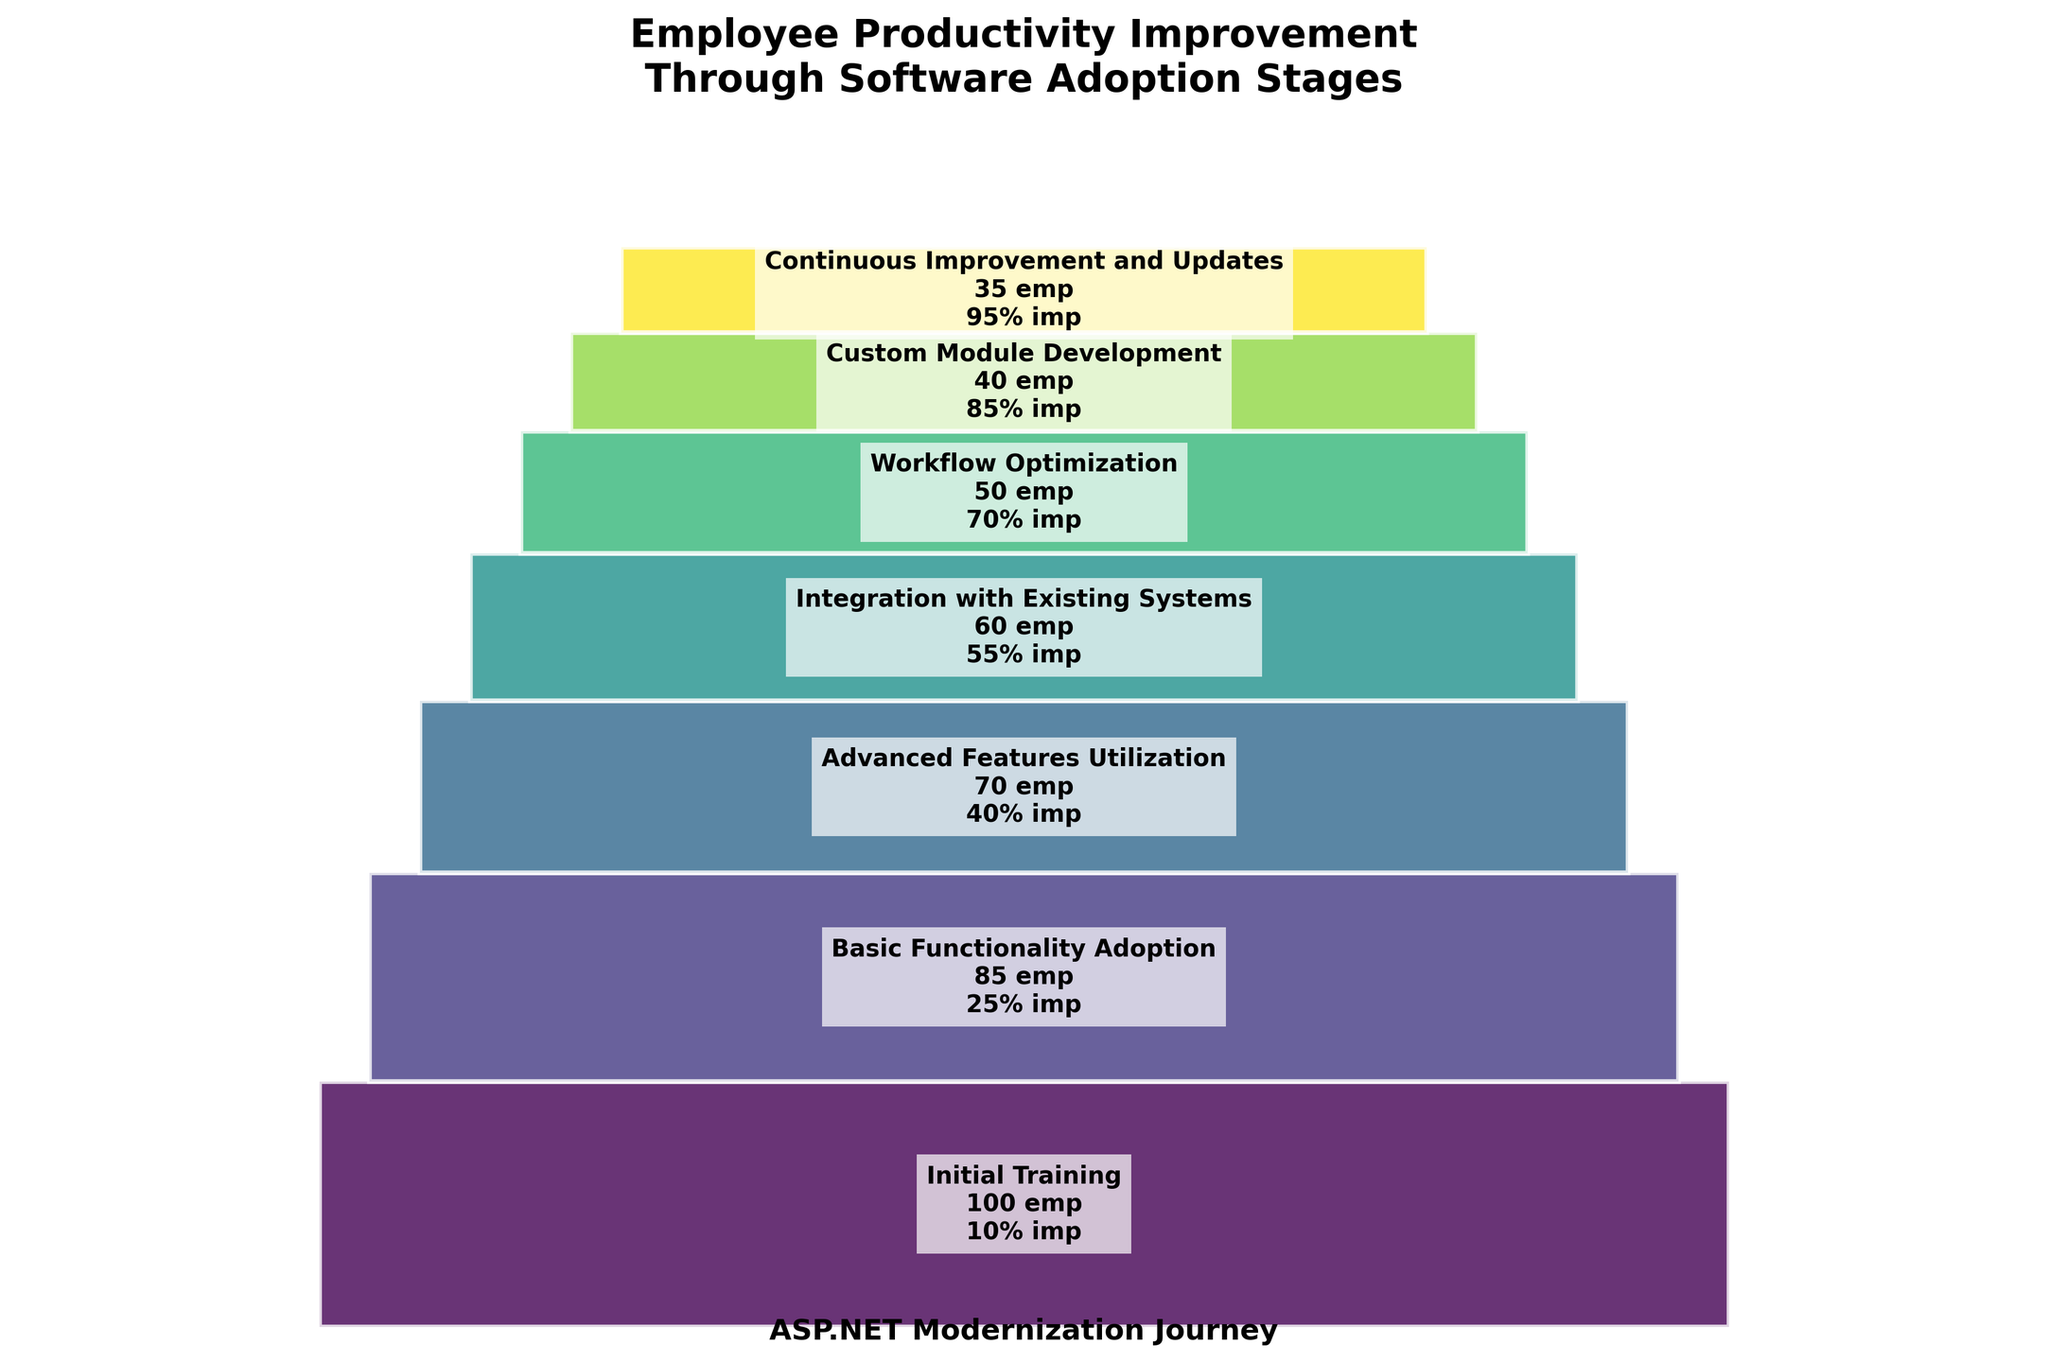What's the title of the plot? The title is usually at the top of the plot, providing a summary of the information depicted. In this case, the title reads: "Employee Productivity Improvement Through Software Adoption Stages".
Answer: Employee Productivity Improvement Through Software Adoption Stages Which stage has the highest number of employees? By observing the height of the bars, the first stage "Initial Training" has the highest number of employees at 100.
Answer: Initial Training What is the smallest productivity improvement percentage and at which stage does it occur? The smallest productivity improvement percentage is displayed along with each stage. The "Initial Training" stage has the smallest improvement at 10%.
Answer: 10% at Initial Training How many stages are depicted in the plot? Count the number of unique stages mentioned in the plot. There are 7 stages in this plot.
Answer: 7 In which stage do we see a productivity improvement of 55%? Look for the stage that shows "55% imp". The stage is "Integration with Existing Systems".
Answer: Integration with Existing Systems By how many employees does the number decrease from "Initial Training" to "Basic Functionality Adoption"? Subtract the number of employees in "Basic Functionality Adoption" (85) from the number of employees in "Initial Training" (100). The difference is 15 employees.
Answer: 15 What's the total number of employees across all stages? Sum up the number of employees at each stage: 100 + 85 + 70 + 60 + 50 + 40 + 35 = 440.
Answer: 440 Which stage has the highest productivity improvement percentage? Among the percentages listed for each stage, the highest one is 95% at the "Continuous Improvement and Updates" stage.
Answer: Continuous Improvement and Updates Compare the number of employees between "Basic Functionality Adoption" and "Advanced Features Utilization". Which one has more employees and by how many? Compare the number of employees: 85 (Basic Functionality Adoption) - 70 (Advanced Features Utilization) = 15. "Basic Functionality Adoption" has 15 more employees.
Answer: Basic Functionality Adoption by 15 How does the productivity improvement change from "Workflow Optimization" to "Custom Module Development"? Note the productivity improvement values: 70% (Workflow Optimization) and 85% (Custom Module Development). The change is an increase of 15 percentage points.
Answer: Increases by 15 percentage points 